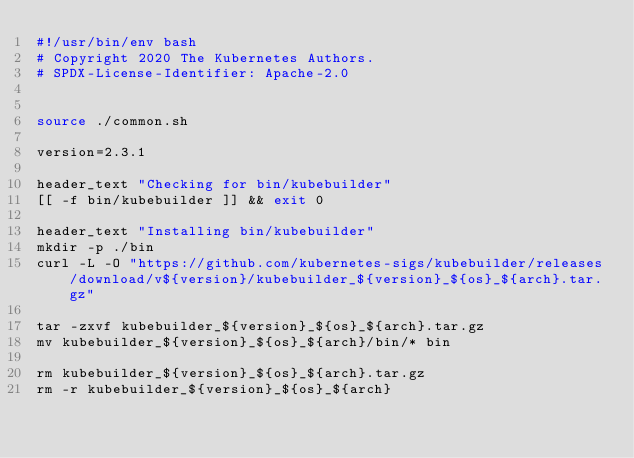<code> <loc_0><loc_0><loc_500><loc_500><_Bash_>#!/usr/bin/env bash
# Copyright 2020 The Kubernetes Authors.
# SPDX-License-Identifier: Apache-2.0


source ./common.sh

version=2.3.1

header_text "Checking for bin/kubebuilder"
[[ -f bin/kubebuilder ]] && exit 0

header_text "Installing bin/kubebuilder"
mkdir -p ./bin
curl -L -O "https://github.com/kubernetes-sigs/kubebuilder/releases/download/v${version}/kubebuilder_${version}_${os}_${arch}.tar.gz"

tar -zxvf kubebuilder_${version}_${os}_${arch}.tar.gz
mv kubebuilder_${version}_${os}_${arch}/bin/* bin

rm kubebuilder_${version}_${os}_${arch}.tar.gz
rm -r kubebuilder_${version}_${os}_${arch}
</code> 